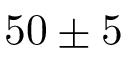Convert formula to latex. <formula><loc_0><loc_0><loc_500><loc_500>5 0 \pm 5</formula> 